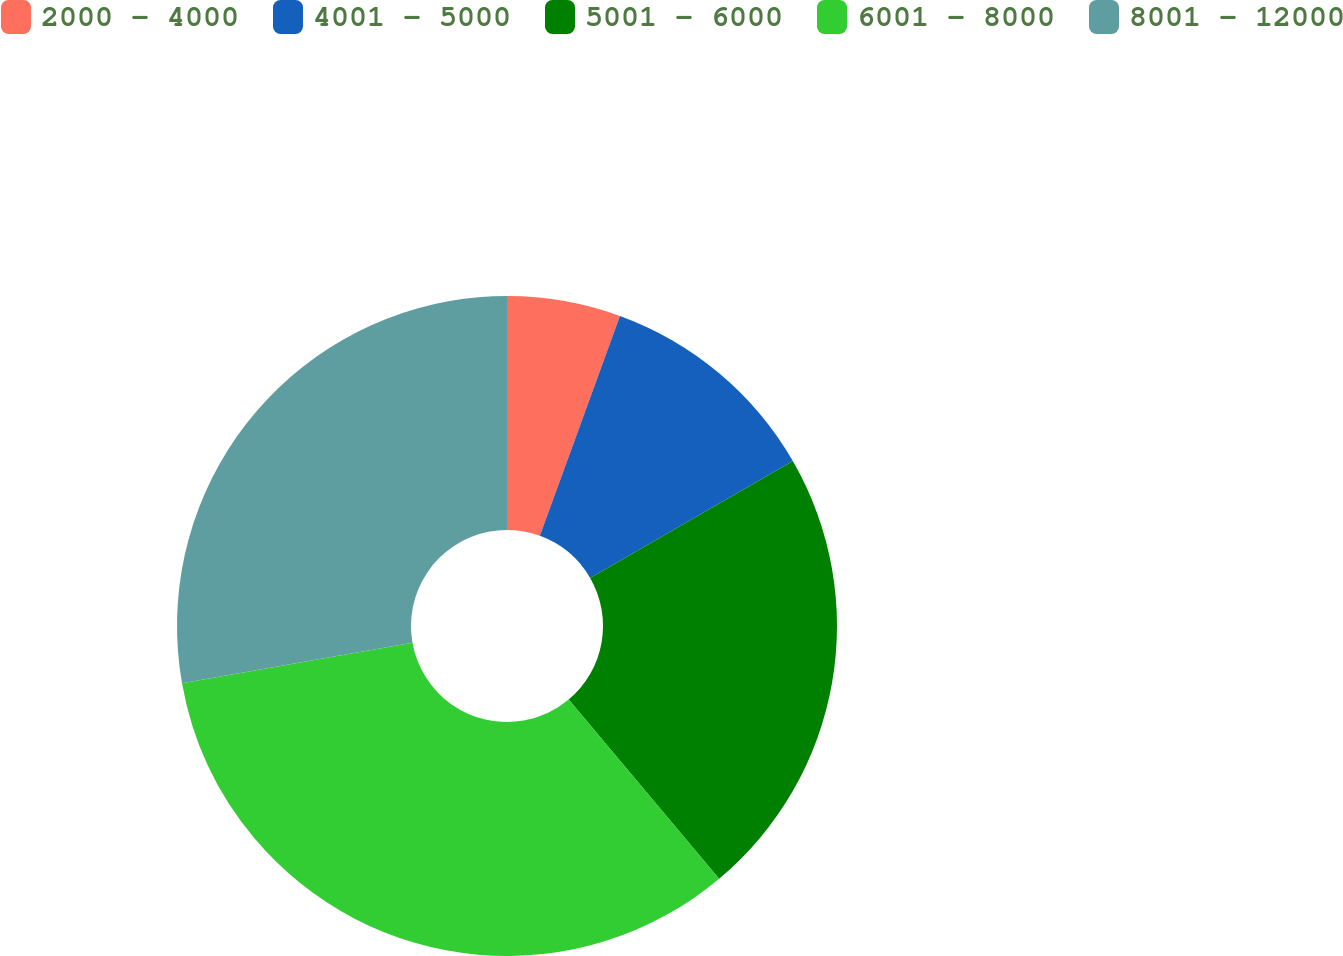<chart> <loc_0><loc_0><loc_500><loc_500><pie_chart><fcel>2000 - 4000<fcel>4001 - 5000<fcel>5001 - 6000<fcel>6001 - 8000<fcel>8001 - 12000<nl><fcel>5.56%<fcel>11.11%<fcel>22.22%<fcel>33.33%<fcel>27.78%<nl></chart> 